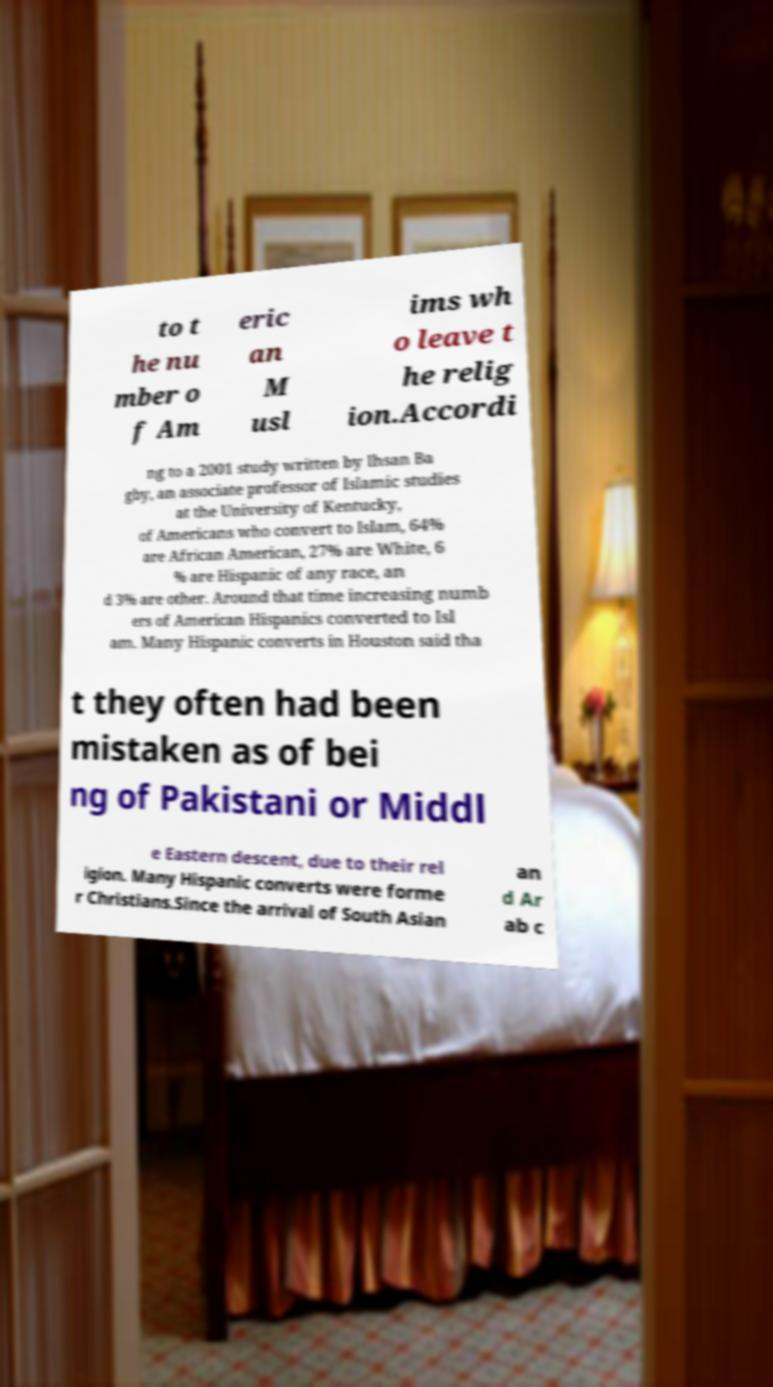Please read and relay the text visible in this image. What does it say? to t he nu mber o f Am eric an M usl ims wh o leave t he relig ion.Accordi ng to a 2001 study written by Ihsan Ba gby, an associate professor of Islamic studies at the University of Kentucky, of Americans who convert to Islam, 64% are African American, 27% are White, 6 % are Hispanic of any race, an d 3% are other. Around that time increasing numb ers of American Hispanics converted to Isl am. Many Hispanic converts in Houston said tha t they often had been mistaken as of bei ng of Pakistani or Middl e Eastern descent, due to their rel igion. Many Hispanic converts were forme r Christians.Since the arrival of South Asian an d Ar ab c 